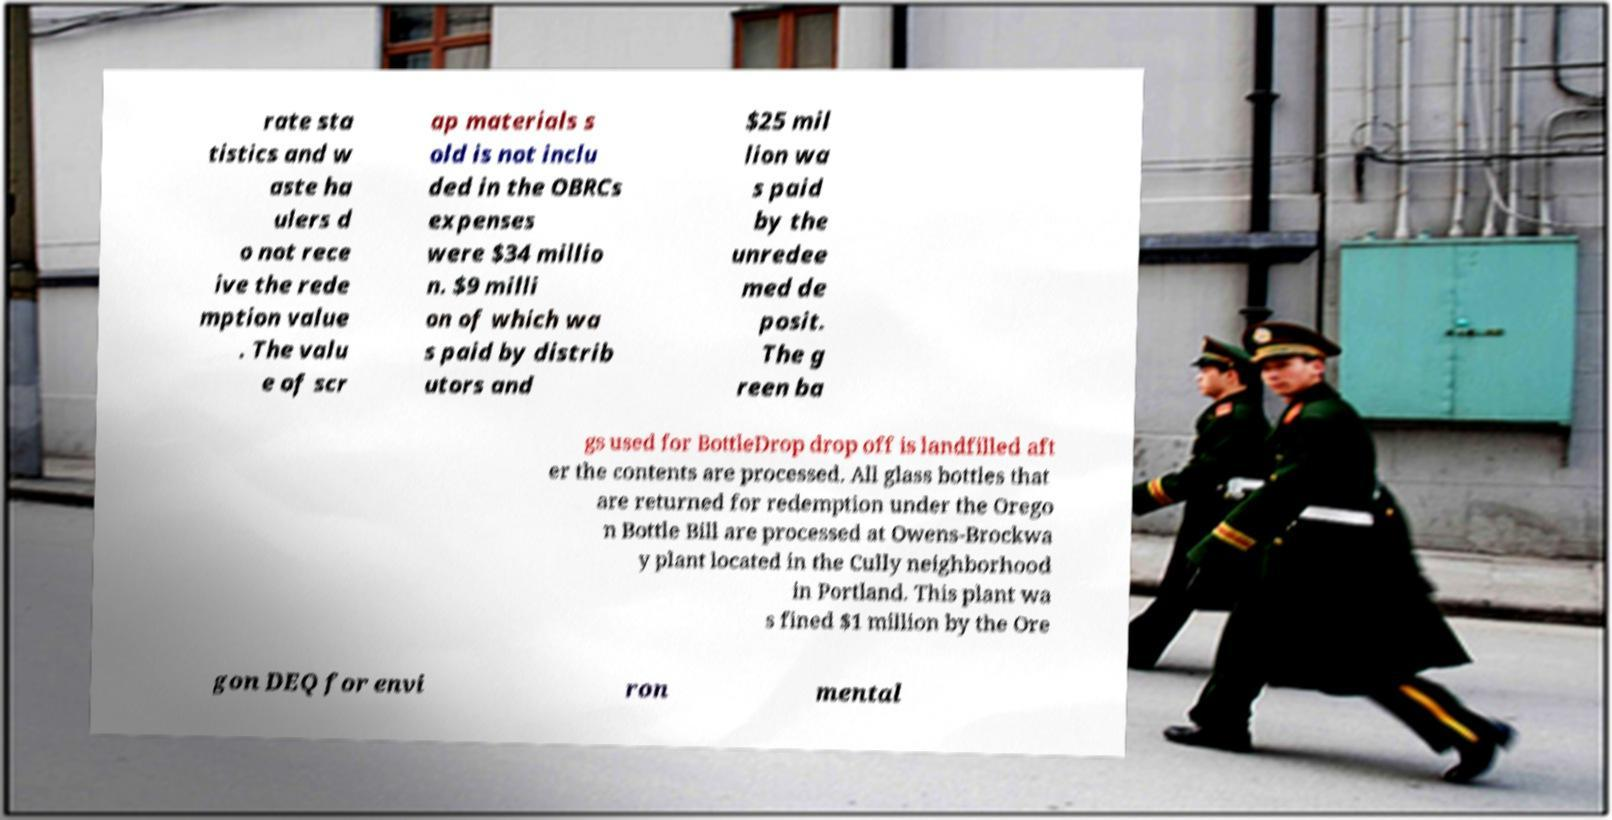Please read and relay the text visible in this image. What does it say? rate sta tistics and w aste ha ulers d o not rece ive the rede mption value . The valu e of scr ap materials s old is not inclu ded in the OBRCs expenses were $34 millio n. $9 milli on of which wa s paid by distrib utors and $25 mil lion wa s paid by the unredee med de posit. The g reen ba gs used for BottleDrop drop off is landfilled aft er the contents are processed. All glass bottles that are returned for redemption under the Orego n Bottle Bill are processed at Owens-Brockwa y plant located in the Cully neighborhood in Portland. This plant wa s fined $1 million by the Ore gon DEQ for envi ron mental 